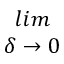Convert formula to latex. <formula><loc_0><loc_0><loc_500><loc_500>\begin{array} { c } { l i m } \\ { \delta \rightarrow 0 } \end{array}</formula> 